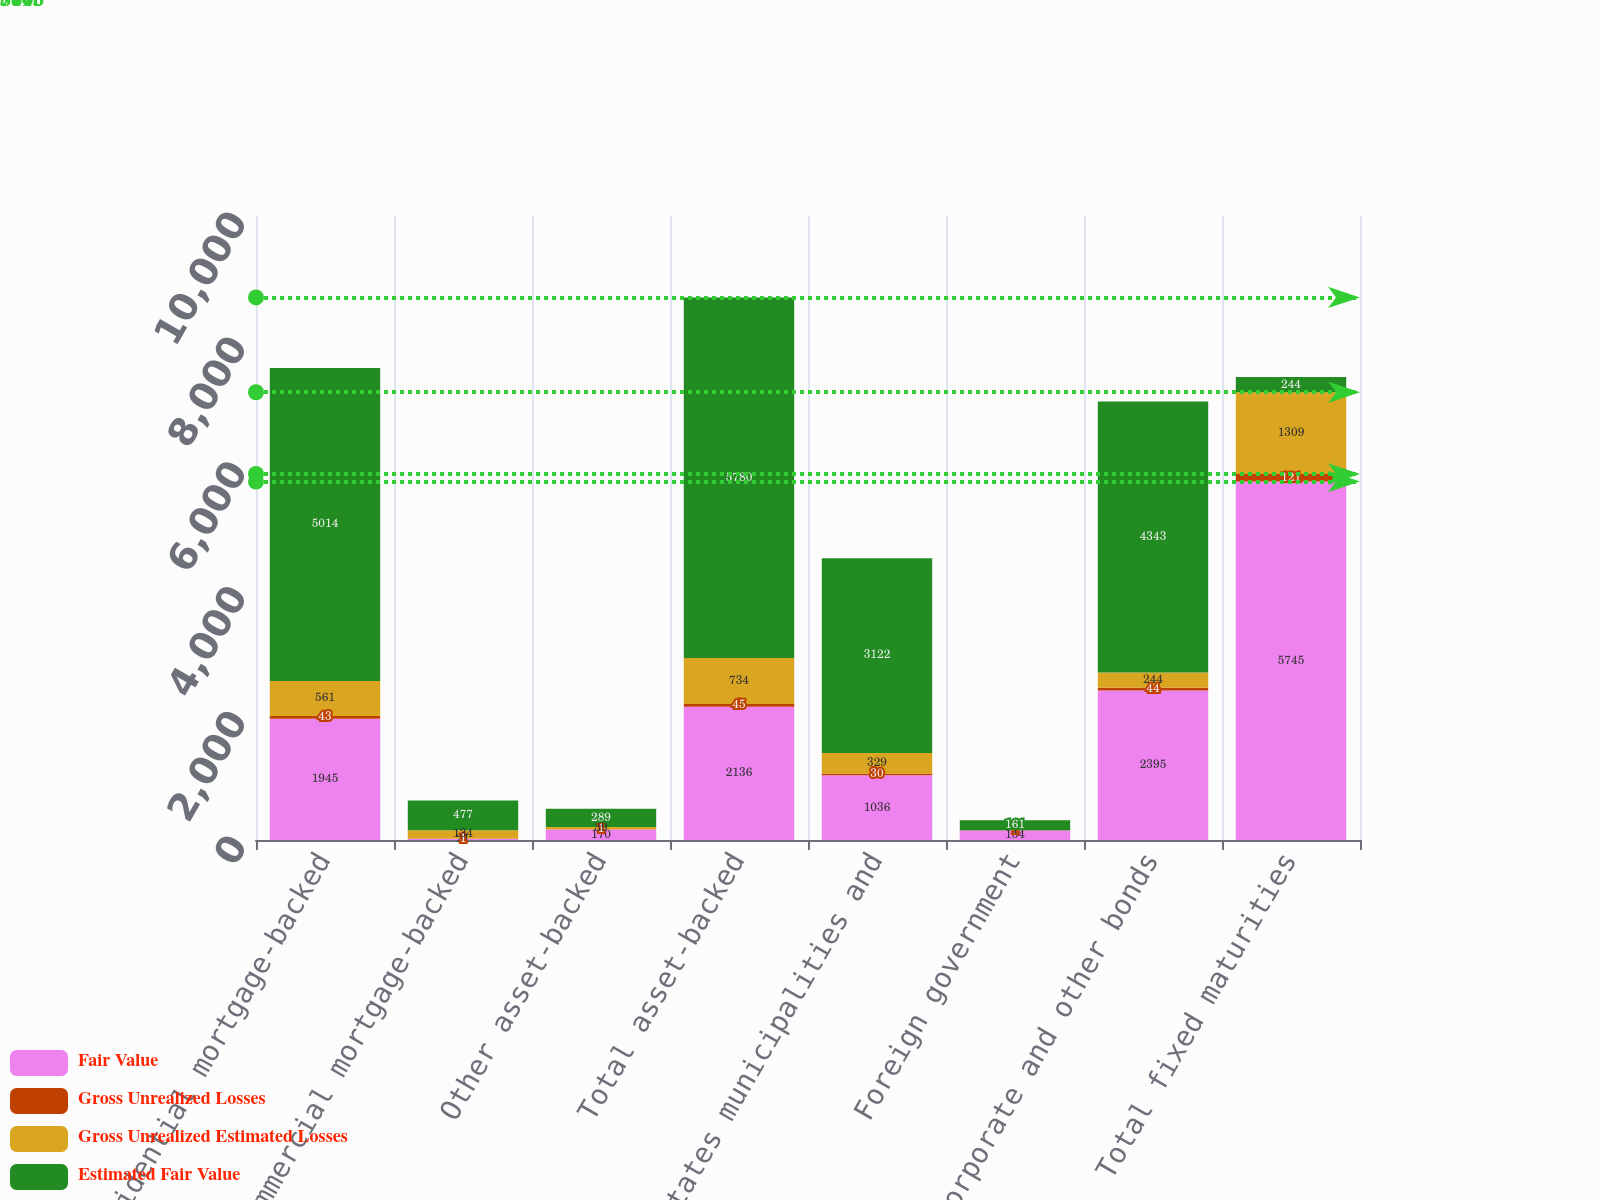Convert chart to OTSL. <chart><loc_0><loc_0><loc_500><loc_500><stacked_bar_chart><ecel><fcel>Residential mortgage-backed<fcel>Commercial mortgage-backed<fcel>Other asset-backed<fcel>Total asset-backed<fcel>States municipalities and<fcel>Foreign government<fcel>Corporate and other bonds<fcel>Total fixed maturities<nl><fcel>Fair Value<fcel>1945<fcel>21<fcel>170<fcel>2136<fcel>1036<fcel>154<fcel>2395<fcel>5745<nl><fcel>Gross Unrealized Losses<fcel>43<fcel>1<fcel>1<fcel>45<fcel>30<fcel>1<fcel>44<fcel>121<nl><fcel>Gross Unrealized Estimated Losses<fcel>561<fcel>134<fcel>39<fcel>734<fcel>329<fcel>1<fcel>244<fcel>1309<nl><fcel>Estimated Fair Value<fcel>5014<fcel>477<fcel>289<fcel>5780<fcel>3122<fcel>161<fcel>4343<fcel>244<nl></chart> 